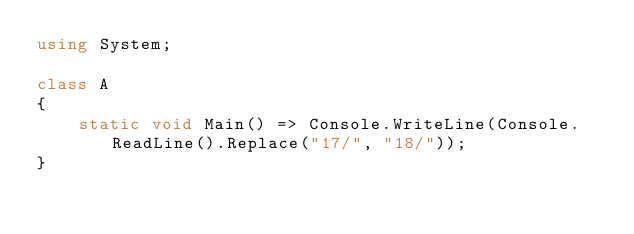<code> <loc_0><loc_0><loc_500><loc_500><_C#_>using System;

class A
{
	static void Main() => Console.WriteLine(Console.ReadLine().Replace("17/", "18/"));
}
</code> 